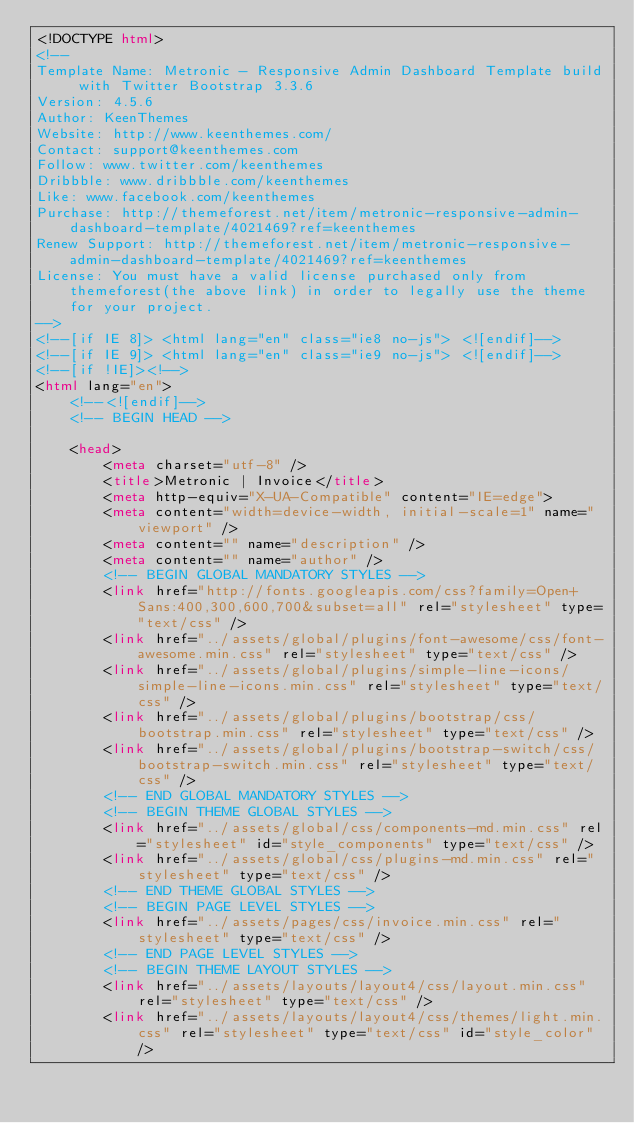<code> <loc_0><loc_0><loc_500><loc_500><_HTML_><!DOCTYPE html>
<!-- 
Template Name: Metronic - Responsive Admin Dashboard Template build with Twitter Bootstrap 3.3.6
Version: 4.5.6
Author: KeenThemes
Website: http://www.keenthemes.com/
Contact: support@keenthemes.com
Follow: www.twitter.com/keenthemes
Dribbble: www.dribbble.com/keenthemes
Like: www.facebook.com/keenthemes
Purchase: http://themeforest.net/item/metronic-responsive-admin-dashboard-template/4021469?ref=keenthemes
Renew Support: http://themeforest.net/item/metronic-responsive-admin-dashboard-template/4021469?ref=keenthemes
License: You must have a valid license purchased only from themeforest(the above link) in order to legally use the theme for your project.
-->
<!--[if IE 8]> <html lang="en" class="ie8 no-js"> <![endif]-->
<!--[if IE 9]> <html lang="en" class="ie9 no-js"> <![endif]-->
<!--[if !IE]><!-->
<html lang="en">
    <!--<![endif]-->
    <!-- BEGIN HEAD -->

    <head>
        <meta charset="utf-8" />
        <title>Metronic | Invoice</title>
        <meta http-equiv="X-UA-Compatible" content="IE=edge">
        <meta content="width=device-width, initial-scale=1" name="viewport" />
        <meta content="" name="description" />
        <meta content="" name="author" />
        <!-- BEGIN GLOBAL MANDATORY STYLES -->
        <link href="http://fonts.googleapis.com/css?family=Open+Sans:400,300,600,700&subset=all" rel="stylesheet" type="text/css" />
        <link href="../assets/global/plugins/font-awesome/css/font-awesome.min.css" rel="stylesheet" type="text/css" />
        <link href="../assets/global/plugins/simple-line-icons/simple-line-icons.min.css" rel="stylesheet" type="text/css" />
        <link href="../assets/global/plugins/bootstrap/css/bootstrap.min.css" rel="stylesheet" type="text/css" />
        <link href="../assets/global/plugins/bootstrap-switch/css/bootstrap-switch.min.css" rel="stylesheet" type="text/css" />
        <!-- END GLOBAL MANDATORY STYLES -->
        <!-- BEGIN THEME GLOBAL STYLES -->
        <link href="../assets/global/css/components-md.min.css" rel="stylesheet" id="style_components" type="text/css" />
        <link href="../assets/global/css/plugins-md.min.css" rel="stylesheet" type="text/css" />
        <!-- END THEME GLOBAL STYLES -->
        <!-- BEGIN PAGE LEVEL STYLES -->
        <link href="../assets/pages/css/invoice.min.css" rel="stylesheet" type="text/css" />
        <!-- END PAGE LEVEL STYLES -->
        <!-- BEGIN THEME LAYOUT STYLES -->
        <link href="../assets/layouts/layout4/css/layout.min.css" rel="stylesheet" type="text/css" />
        <link href="../assets/layouts/layout4/css/themes/light.min.css" rel="stylesheet" type="text/css" id="style_color" /></code> 